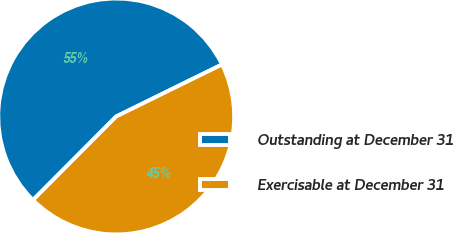<chart> <loc_0><loc_0><loc_500><loc_500><pie_chart><fcel>Outstanding at December 31<fcel>Exercisable at December 31<nl><fcel>55.26%<fcel>44.74%<nl></chart> 